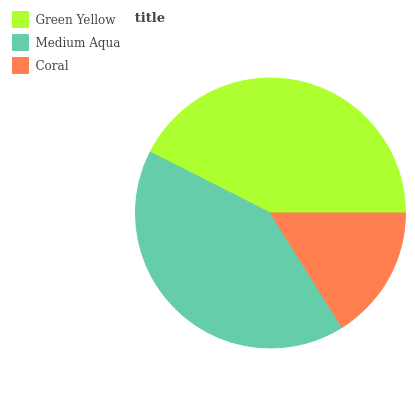Is Coral the minimum?
Answer yes or no. Yes. Is Green Yellow the maximum?
Answer yes or no. Yes. Is Medium Aqua the minimum?
Answer yes or no. No. Is Medium Aqua the maximum?
Answer yes or no. No. Is Green Yellow greater than Medium Aqua?
Answer yes or no. Yes. Is Medium Aqua less than Green Yellow?
Answer yes or no. Yes. Is Medium Aqua greater than Green Yellow?
Answer yes or no. No. Is Green Yellow less than Medium Aqua?
Answer yes or no. No. Is Medium Aqua the high median?
Answer yes or no. Yes. Is Medium Aqua the low median?
Answer yes or no. Yes. Is Green Yellow the high median?
Answer yes or no. No. Is Coral the low median?
Answer yes or no. No. 